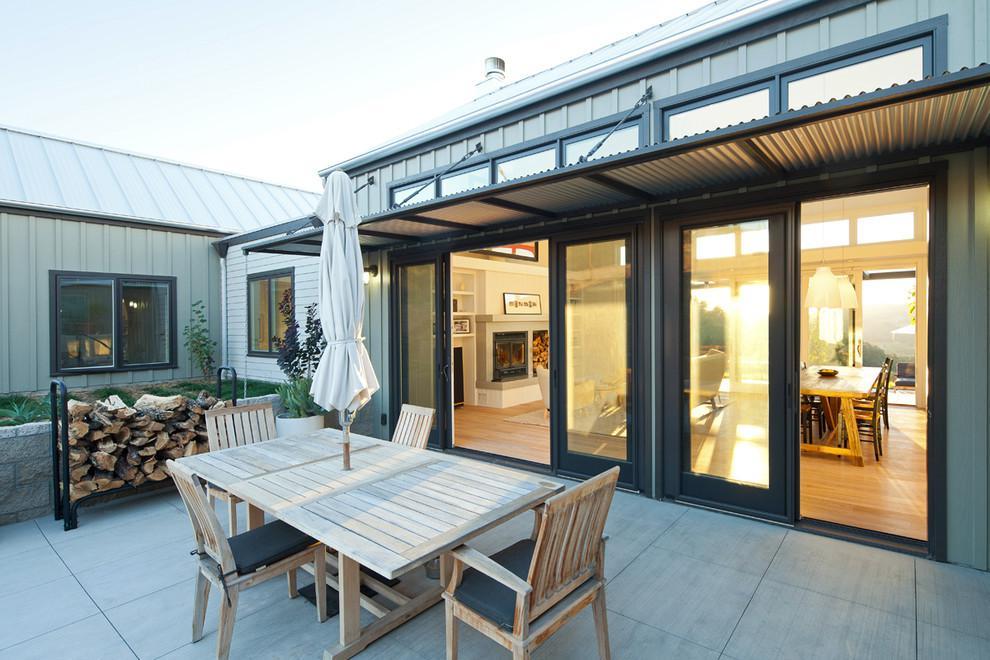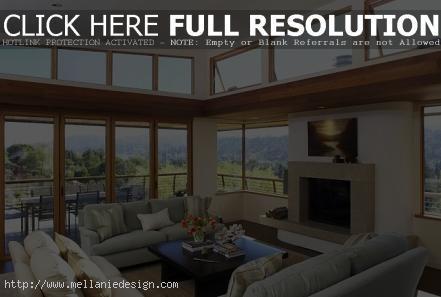The first image is the image on the left, the second image is the image on the right. Analyze the images presented: Is the assertion "In at least one image there is at least one hanging wooden door on a track." valid? Answer yes or no. No. 